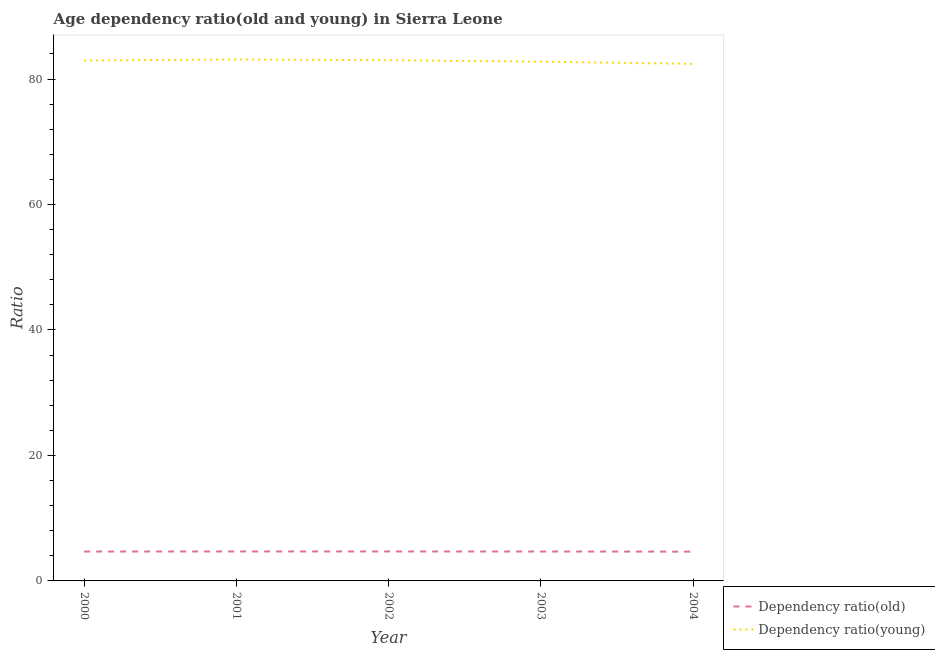How many different coloured lines are there?
Offer a terse response. 2. Is the number of lines equal to the number of legend labels?
Keep it short and to the point. Yes. What is the age dependency ratio(old) in 2000?
Keep it short and to the point. 4.68. Across all years, what is the maximum age dependency ratio(young)?
Give a very brief answer. 83.12. Across all years, what is the minimum age dependency ratio(young)?
Offer a very short reply. 82.42. In which year was the age dependency ratio(young) maximum?
Your answer should be very brief. 2001. What is the total age dependency ratio(young) in the graph?
Offer a terse response. 414.26. What is the difference between the age dependency ratio(old) in 2002 and that in 2003?
Provide a short and direct response. 0.01. What is the difference between the age dependency ratio(young) in 2003 and the age dependency ratio(old) in 2002?
Provide a short and direct response. 78.07. What is the average age dependency ratio(young) per year?
Give a very brief answer. 82.85. In the year 2001, what is the difference between the age dependency ratio(old) and age dependency ratio(young)?
Your answer should be very brief. -78.42. In how many years, is the age dependency ratio(old) greater than 52?
Your answer should be compact. 0. What is the ratio of the age dependency ratio(old) in 2000 to that in 2002?
Offer a terse response. 1. Is the difference between the age dependency ratio(young) in 2002 and 2004 greater than the difference between the age dependency ratio(old) in 2002 and 2004?
Offer a very short reply. Yes. What is the difference between the highest and the second highest age dependency ratio(old)?
Your answer should be very brief. 0. What is the difference between the highest and the lowest age dependency ratio(young)?
Offer a very short reply. 0.69. In how many years, is the age dependency ratio(young) greater than the average age dependency ratio(young) taken over all years?
Provide a succinct answer. 3. How many lines are there?
Offer a very short reply. 2. Are the values on the major ticks of Y-axis written in scientific E-notation?
Keep it short and to the point. No. How are the legend labels stacked?
Your response must be concise. Vertical. What is the title of the graph?
Keep it short and to the point. Age dependency ratio(old and young) in Sierra Leone. What is the label or title of the Y-axis?
Ensure brevity in your answer.  Ratio. What is the Ratio of Dependency ratio(old) in 2000?
Offer a very short reply. 4.68. What is the Ratio of Dependency ratio(young) in 2000?
Ensure brevity in your answer.  82.95. What is the Ratio in Dependency ratio(old) in 2001?
Offer a terse response. 4.7. What is the Ratio in Dependency ratio(young) in 2001?
Make the answer very short. 83.12. What is the Ratio in Dependency ratio(old) in 2002?
Offer a very short reply. 4.7. What is the Ratio in Dependency ratio(young) in 2002?
Your answer should be compact. 83. What is the Ratio of Dependency ratio(old) in 2003?
Your answer should be very brief. 4.69. What is the Ratio in Dependency ratio(young) in 2003?
Offer a very short reply. 82.77. What is the Ratio of Dependency ratio(old) in 2004?
Your answer should be very brief. 4.67. What is the Ratio of Dependency ratio(young) in 2004?
Make the answer very short. 82.42. Across all years, what is the maximum Ratio of Dependency ratio(old)?
Make the answer very short. 4.7. Across all years, what is the maximum Ratio in Dependency ratio(young)?
Your answer should be compact. 83.12. Across all years, what is the minimum Ratio of Dependency ratio(old)?
Make the answer very short. 4.67. Across all years, what is the minimum Ratio in Dependency ratio(young)?
Your answer should be compact. 82.42. What is the total Ratio in Dependency ratio(old) in the graph?
Provide a short and direct response. 23.43. What is the total Ratio of Dependency ratio(young) in the graph?
Offer a terse response. 414.26. What is the difference between the Ratio of Dependency ratio(old) in 2000 and that in 2001?
Keep it short and to the point. -0.02. What is the difference between the Ratio of Dependency ratio(young) in 2000 and that in 2001?
Offer a terse response. -0.16. What is the difference between the Ratio of Dependency ratio(old) in 2000 and that in 2002?
Provide a succinct answer. -0.01. What is the difference between the Ratio of Dependency ratio(young) in 2000 and that in 2002?
Ensure brevity in your answer.  -0.05. What is the difference between the Ratio of Dependency ratio(old) in 2000 and that in 2003?
Provide a succinct answer. -0. What is the difference between the Ratio of Dependency ratio(young) in 2000 and that in 2003?
Provide a short and direct response. 0.18. What is the difference between the Ratio of Dependency ratio(old) in 2000 and that in 2004?
Offer a very short reply. 0.01. What is the difference between the Ratio in Dependency ratio(young) in 2000 and that in 2004?
Keep it short and to the point. 0.53. What is the difference between the Ratio of Dependency ratio(old) in 2001 and that in 2002?
Offer a terse response. 0. What is the difference between the Ratio in Dependency ratio(young) in 2001 and that in 2002?
Your response must be concise. 0.11. What is the difference between the Ratio in Dependency ratio(old) in 2001 and that in 2003?
Offer a very short reply. 0.01. What is the difference between the Ratio in Dependency ratio(young) in 2001 and that in 2003?
Provide a short and direct response. 0.35. What is the difference between the Ratio of Dependency ratio(old) in 2001 and that in 2004?
Your response must be concise. 0.03. What is the difference between the Ratio in Dependency ratio(young) in 2001 and that in 2004?
Offer a very short reply. 0.69. What is the difference between the Ratio in Dependency ratio(old) in 2002 and that in 2003?
Ensure brevity in your answer.  0.01. What is the difference between the Ratio of Dependency ratio(young) in 2002 and that in 2003?
Provide a short and direct response. 0.24. What is the difference between the Ratio in Dependency ratio(old) in 2002 and that in 2004?
Your response must be concise. 0.03. What is the difference between the Ratio of Dependency ratio(young) in 2002 and that in 2004?
Provide a succinct answer. 0.58. What is the difference between the Ratio of Dependency ratio(old) in 2003 and that in 2004?
Provide a succinct answer. 0.01. What is the difference between the Ratio of Dependency ratio(young) in 2003 and that in 2004?
Your answer should be very brief. 0.35. What is the difference between the Ratio in Dependency ratio(old) in 2000 and the Ratio in Dependency ratio(young) in 2001?
Keep it short and to the point. -78.43. What is the difference between the Ratio in Dependency ratio(old) in 2000 and the Ratio in Dependency ratio(young) in 2002?
Provide a short and direct response. -78.32. What is the difference between the Ratio of Dependency ratio(old) in 2000 and the Ratio of Dependency ratio(young) in 2003?
Provide a succinct answer. -78.08. What is the difference between the Ratio in Dependency ratio(old) in 2000 and the Ratio in Dependency ratio(young) in 2004?
Make the answer very short. -77.74. What is the difference between the Ratio in Dependency ratio(old) in 2001 and the Ratio in Dependency ratio(young) in 2002?
Provide a short and direct response. -78.3. What is the difference between the Ratio of Dependency ratio(old) in 2001 and the Ratio of Dependency ratio(young) in 2003?
Ensure brevity in your answer.  -78.07. What is the difference between the Ratio of Dependency ratio(old) in 2001 and the Ratio of Dependency ratio(young) in 2004?
Make the answer very short. -77.72. What is the difference between the Ratio of Dependency ratio(old) in 2002 and the Ratio of Dependency ratio(young) in 2003?
Make the answer very short. -78.07. What is the difference between the Ratio of Dependency ratio(old) in 2002 and the Ratio of Dependency ratio(young) in 2004?
Provide a succinct answer. -77.72. What is the difference between the Ratio of Dependency ratio(old) in 2003 and the Ratio of Dependency ratio(young) in 2004?
Offer a terse response. -77.74. What is the average Ratio of Dependency ratio(old) per year?
Ensure brevity in your answer.  4.69. What is the average Ratio of Dependency ratio(young) per year?
Offer a terse response. 82.85. In the year 2000, what is the difference between the Ratio of Dependency ratio(old) and Ratio of Dependency ratio(young)?
Make the answer very short. -78.27. In the year 2001, what is the difference between the Ratio in Dependency ratio(old) and Ratio in Dependency ratio(young)?
Make the answer very short. -78.42. In the year 2002, what is the difference between the Ratio of Dependency ratio(old) and Ratio of Dependency ratio(young)?
Your answer should be compact. -78.31. In the year 2003, what is the difference between the Ratio in Dependency ratio(old) and Ratio in Dependency ratio(young)?
Ensure brevity in your answer.  -78.08. In the year 2004, what is the difference between the Ratio in Dependency ratio(old) and Ratio in Dependency ratio(young)?
Make the answer very short. -77.75. What is the ratio of the Ratio in Dependency ratio(young) in 2000 to that in 2001?
Offer a very short reply. 1. What is the ratio of the Ratio in Dependency ratio(old) in 2000 to that in 2002?
Provide a short and direct response. 1. What is the ratio of the Ratio in Dependency ratio(old) in 2000 to that in 2003?
Your answer should be very brief. 1. What is the ratio of the Ratio in Dependency ratio(young) in 2000 to that in 2003?
Make the answer very short. 1. What is the ratio of the Ratio of Dependency ratio(old) in 2000 to that in 2004?
Offer a very short reply. 1. What is the ratio of the Ratio in Dependency ratio(young) in 2000 to that in 2004?
Provide a short and direct response. 1.01. What is the ratio of the Ratio in Dependency ratio(young) in 2001 to that in 2002?
Your answer should be compact. 1. What is the ratio of the Ratio in Dependency ratio(young) in 2001 to that in 2003?
Make the answer very short. 1. What is the ratio of the Ratio of Dependency ratio(old) in 2001 to that in 2004?
Keep it short and to the point. 1.01. What is the ratio of the Ratio of Dependency ratio(young) in 2001 to that in 2004?
Provide a succinct answer. 1.01. What is the ratio of the Ratio of Dependency ratio(young) in 2002 to that in 2003?
Make the answer very short. 1. What is the ratio of the Ratio in Dependency ratio(old) in 2002 to that in 2004?
Your answer should be very brief. 1.01. What is the ratio of the Ratio in Dependency ratio(young) in 2003 to that in 2004?
Give a very brief answer. 1. What is the difference between the highest and the second highest Ratio of Dependency ratio(old)?
Provide a short and direct response. 0. What is the difference between the highest and the second highest Ratio in Dependency ratio(young)?
Make the answer very short. 0.11. What is the difference between the highest and the lowest Ratio in Dependency ratio(old)?
Keep it short and to the point. 0.03. What is the difference between the highest and the lowest Ratio of Dependency ratio(young)?
Your answer should be very brief. 0.69. 